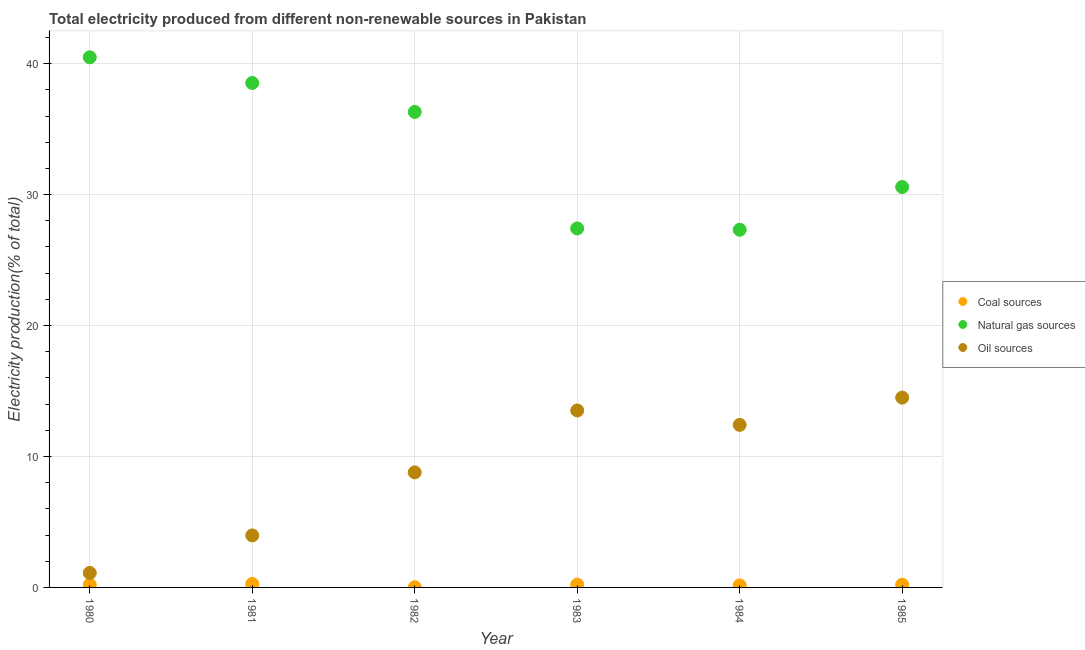How many different coloured dotlines are there?
Offer a terse response. 3. What is the percentage of electricity produced by natural gas in 1981?
Provide a succinct answer. 38.53. Across all years, what is the maximum percentage of electricity produced by natural gas?
Your response must be concise. 40.48. Across all years, what is the minimum percentage of electricity produced by coal?
Provide a short and direct response. 0.02. In which year was the percentage of electricity produced by coal maximum?
Your answer should be very brief. 1981. In which year was the percentage of electricity produced by coal minimum?
Give a very brief answer. 1982. What is the total percentage of electricity produced by natural gas in the graph?
Keep it short and to the point. 200.63. What is the difference between the percentage of electricity produced by coal in 1980 and that in 1985?
Give a very brief answer. -0. What is the difference between the percentage of electricity produced by natural gas in 1982 and the percentage of electricity produced by coal in 1980?
Your answer should be very brief. 36.11. What is the average percentage of electricity produced by natural gas per year?
Provide a short and direct response. 33.44. In the year 1980, what is the difference between the percentage of electricity produced by coal and percentage of electricity produced by oil sources?
Keep it short and to the point. -0.91. What is the ratio of the percentage of electricity produced by natural gas in 1981 to that in 1985?
Ensure brevity in your answer.  1.26. Is the percentage of electricity produced by oil sources in 1981 less than that in 1985?
Your answer should be compact. Yes. What is the difference between the highest and the second highest percentage of electricity produced by coal?
Ensure brevity in your answer.  0.05. What is the difference between the highest and the lowest percentage of electricity produced by oil sources?
Ensure brevity in your answer.  13.39. In how many years, is the percentage of electricity produced by natural gas greater than the average percentage of electricity produced by natural gas taken over all years?
Keep it short and to the point. 3. Is it the case that in every year, the sum of the percentage of electricity produced by coal and percentage of electricity produced by natural gas is greater than the percentage of electricity produced by oil sources?
Provide a succinct answer. Yes. How many years are there in the graph?
Your response must be concise. 6. What is the difference between two consecutive major ticks on the Y-axis?
Offer a terse response. 10. How are the legend labels stacked?
Your answer should be compact. Vertical. What is the title of the graph?
Give a very brief answer. Total electricity produced from different non-renewable sources in Pakistan. What is the label or title of the X-axis?
Offer a very short reply. Year. What is the Electricity production(% of total) in Coal sources in 1980?
Your answer should be compact. 0.2. What is the Electricity production(% of total) in Natural gas sources in 1980?
Ensure brevity in your answer.  40.48. What is the Electricity production(% of total) of Oil sources in 1980?
Your answer should be compact. 1.11. What is the Electricity production(% of total) of Coal sources in 1981?
Your response must be concise. 0.27. What is the Electricity production(% of total) of Natural gas sources in 1981?
Provide a short and direct response. 38.53. What is the Electricity production(% of total) in Oil sources in 1981?
Keep it short and to the point. 3.97. What is the Electricity production(% of total) in Coal sources in 1982?
Offer a very short reply. 0.02. What is the Electricity production(% of total) of Natural gas sources in 1982?
Your answer should be compact. 36.31. What is the Electricity production(% of total) in Oil sources in 1982?
Your response must be concise. 8.79. What is the Electricity production(% of total) in Coal sources in 1983?
Offer a terse response. 0.21. What is the Electricity production(% of total) of Natural gas sources in 1983?
Provide a succinct answer. 27.42. What is the Electricity production(% of total) of Oil sources in 1983?
Offer a terse response. 13.51. What is the Electricity production(% of total) in Coal sources in 1984?
Your response must be concise. 0.16. What is the Electricity production(% of total) in Natural gas sources in 1984?
Give a very brief answer. 27.31. What is the Electricity production(% of total) of Oil sources in 1984?
Your answer should be compact. 12.41. What is the Electricity production(% of total) of Coal sources in 1985?
Your answer should be compact. 0.2. What is the Electricity production(% of total) in Natural gas sources in 1985?
Offer a terse response. 30.58. What is the Electricity production(% of total) of Oil sources in 1985?
Your answer should be very brief. 14.5. Across all years, what is the maximum Electricity production(% of total) in Coal sources?
Provide a short and direct response. 0.27. Across all years, what is the maximum Electricity production(% of total) in Natural gas sources?
Offer a very short reply. 40.48. Across all years, what is the maximum Electricity production(% of total) of Oil sources?
Your response must be concise. 14.5. Across all years, what is the minimum Electricity production(% of total) of Coal sources?
Your answer should be very brief. 0.02. Across all years, what is the minimum Electricity production(% of total) in Natural gas sources?
Ensure brevity in your answer.  27.31. Across all years, what is the minimum Electricity production(% of total) in Oil sources?
Provide a short and direct response. 1.11. What is the total Electricity production(% of total) of Coal sources in the graph?
Offer a terse response. 1.06. What is the total Electricity production(% of total) in Natural gas sources in the graph?
Give a very brief answer. 200.63. What is the total Electricity production(% of total) in Oil sources in the graph?
Your response must be concise. 54.29. What is the difference between the Electricity production(% of total) of Coal sources in 1980 and that in 1981?
Offer a terse response. -0.07. What is the difference between the Electricity production(% of total) of Natural gas sources in 1980 and that in 1981?
Ensure brevity in your answer.  1.96. What is the difference between the Electricity production(% of total) of Oil sources in 1980 and that in 1981?
Your response must be concise. -2.86. What is the difference between the Electricity production(% of total) of Coal sources in 1980 and that in 1982?
Provide a succinct answer. 0.18. What is the difference between the Electricity production(% of total) in Natural gas sources in 1980 and that in 1982?
Your response must be concise. 4.17. What is the difference between the Electricity production(% of total) of Oil sources in 1980 and that in 1982?
Your response must be concise. -7.68. What is the difference between the Electricity production(% of total) of Coal sources in 1980 and that in 1983?
Your answer should be compact. -0.01. What is the difference between the Electricity production(% of total) of Natural gas sources in 1980 and that in 1983?
Give a very brief answer. 13.07. What is the difference between the Electricity production(% of total) in Oil sources in 1980 and that in 1983?
Your answer should be very brief. -12.41. What is the difference between the Electricity production(% of total) of Coal sources in 1980 and that in 1984?
Ensure brevity in your answer.  0.04. What is the difference between the Electricity production(% of total) of Natural gas sources in 1980 and that in 1984?
Your response must be concise. 13.17. What is the difference between the Electricity production(% of total) in Oil sources in 1980 and that in 1984?
Your response must be concise. -11.3. What is the difference between the Electricity production(% of total) in Coal sources in 1980 and that in 1985?
Keep it short and to the point. -0. What is the difference between the Electricity production(% of total) in Natural gas sources in 1980 and that in 1985?
Your answer should be compact. 9.9. What is the difference between the Electricity production(% of total) of Oil sources in 1980 and that in 1985?
Ensure brevity in your answer.  -13.39. What is the difference between the Electricity production(% of total) of Coal sources in 1981 and that in 1982?
Provide a short and direct response. 0.25. What is the difference between the Electricity production(% of total) in Natural gas sources in 1981 and that in 1982?
Make the answer very short. 2.21. What is the difference between the Electricity production(% of total) in Oil sources in 1981 and that in 1982?
Your response must be concise. -4.81. What is the difference between the Electricity production(% of total) of Coal sources in 1981 and that in 1983?
Give a very brief answer. 0.05. What is the difference between the Electricity production(% of total) of Natural gas sources in 1981 and that in 1983?
Your answer should be very brief. 11.11. What is the difference between the Electricity production(% of total) of Oil sources in 1981 and that in 1983?
Give a very brief answer. -9.54. What is the difference between the Electricity production(% of total) of Coal sources in 1981 and that in 1984?
Your answer should be very brief. 0.11. What is the difference between the Electricity production(% of total) in Natural gas sources in 1981 and that in 1984?
Your response must be concise. 11.21. What is the difference between the Electricity production(% of total) of Oil sources in 1981 and that in 1984?
Provide a succinct answer. -8.44. What is the difference between the Electricity production(% of total) of Coal sources in 1981 and that in 1985?
Give a very brief answer. 0.06. What is the difference between the Electricity production(% of total) of Natural gas sources in 1981 and that in 1985?
Your answer should be very brief. 7.95. What is the difference between the Electricity production(% of total) of Oil sources in 1981 and that in 1985?
Ensure brevity in your answer.  -10.53. What is the difference between the Electricity production(% of total) of Coal sources in 1982 and that in 1983?
Make the answer very short. -0.2. What is the difference between the Electricity production(% of total) in Natural gas sources in 1982 and that in 1983?
Your answer should be compact. 8.9. What is the difference between the Electricity production(% of total) of Oil sources in 1982 and that in 1983?
Your response must be concise. -4.73. What is the difference between the Electricity production(% of total) of Coal sources in 1982 and that in 1984?
Provide a short and direct response. -0.14. What is the difference between the Electricity production(% of total) in Natural gas sources in 1982 and that in 1984?
Offer a very short reply. 9. What is the difference between the Electricity production(% of total) of Oil sources in 1982 and that in 1984?
Provide a short and direct response. -3.63. What is the difference between the Electricity production(% of total) in Coal sources in 1982 and that in 1985?
Ensure brevity in your answer.  -0.19. What is the difference between the Electricity production(% of total) of Natural gas sources in 1982 and that in 1985?
Your answer should be very brief. 5.73. What is the difference between the Electricity production(% of total) of Oil sources in 1982 and that in 1985?
Offer a terse response. -5.71. What is the difference between the Electricity production(% of total) in Coal sources in 1983 and that in 1984?
Ensure brevity in your answer.  0.06. What is the difference between the Electricity production(% of total) in Natural gas sources in 1983 and that in 1984?
Offer a very short reply. 0.1. What is the difference between the Electricity production(% of total) in Oil sources in 1983 and that in 1984?
Ensure brevity in your answer.  1.1. What is the difference between the Electricity production(% of total) in Coal sources in 1983 and that in 1985?
Provide a short and direct response. 0.01. What is the difference between the Electricity production(% of total) of Natural gas sources in 1983 and that in 1985?
Your answer should be very brief. -3.16. What is the difference between the Electricity production(% of total) in Oil sources in 1983 and that in 1985?
Provide a succinct answer. -0.98. What is the difference between the Electricity production(% of total) in Coal sources in 1984 and that in 1985?
Offer a very short reply. -0.05. What is the difference between the Electricity production(% of total) in Natural gas sources in 1984 and that in 1985?
Your answer should be compact. -3.27. What is the difference between the Electricity production(% of total) of Oil sources in 1984 and that in 1985?
Your response must be concise. -2.09. What is the difference between the Electricity production(% of total) of Coal sources in 1980 and the Electricity production(% of total) of Natural gas sources in 1981?
Provide a succinct answer. -38.33. What is the difference between the Electricity production(% of total) in Coal sources in 1980 and the Electricity production(% of total) in Oil sources in 1981?
Your answer should be very brief. -3.77. What is the difference between the Electricity production(% of total) in Natural gas sources in 1980 and the Electricity production(% of total) in Oil sources in 1981?
Make the answer very short. 36.51. What is the difference between the Electricity production(% of total) in Coal sources in 1980 and the Electricity production(% of total) in Natural gas sources in 1982?
Your answer should be compact. -36.11. What is the difference between the Electricity production(% of total) of Coal sources in 1980 and the Electricity production(% of total) of Oil sources in 1982?
Provide a succinct answer. -8.59. What is the difference between the Electricity production(% of total) in Natural gas sources in 1980 and the Electricity production(% of total) in Oil sources in 1982?
Give a very brief answer. 31.7. What is the difference between the Electricity production(% of total) in Coal sources in 1980 and the Electricity production(% of total) in Natural gas sources in 1983?
Make the answer very short. -27.21. What is the difference between the Electricity production(% of total) in Coal sources in 1980 and the Electricity production(% of total) in Oil sources in 1983?
Offer a very short reply. -13.31. What is the difference between the Electricity production(% of total) of Natural gas sources in 1980 and the Electricity production(% of total) of Oil sources in 1983?
Provide a succinct answer. 26.97. What is the difference between the Electricity production(% of total) in Coal sources in 1980 and the Electricity production(% of total) in Natural gas sources in 1984?
Give a very brief answer. -27.11. What is the difference between the Electricity production(% of total) in Coal sources in 1980 and the Electricity production(% of total) in Oil sources in 1984?
Keep it short and to the point. -12.21. What is the difference between the Electricity production(% of total) in Natural gas sources in 1980 and the Electricity production(% of total) in Oil sources in 1984?
Offer a very short reply. 28.07. What is the difference between the Electricity production(% of total) in Coal sources in 1980 and the Electricity production(% of total) in Natural gas sources in 1985?
Your answer should be very brief. -30.38. What is the difference between the Electricity production(% of total) in Coal sources in 1980 and the Electricity production(% of total) in Oil sources in 1985?
Your answer should be compact. -14.3. What is the difference between the Electricity production(% of total) in Natural gas sources in 1980 and the Electricity production(% of total) in Oil sources in 1985?
Ensure brevity in your answer.  25.99. What is the difference between the Electricity production(% of total) of Coal sources in 1981 and the Electricity production(% of total) of Natural gas sources in 1982?
Keep it short and to the point. -36.05. What is the difference between the Electricity production(% of total) in Coal sources in 1981 and the Electricity production(% of total) in Oil sources in 1982?
Offer a terse response. -8.52. What is the difference between the Electricity production(% of total) in Natural gas sources in 1981 and the Electricity production(% of total) in Oil sources in 1982?
Make the answer very short. 29.74. What is the difference between the Electricity production(% of total) in Coal sources in 1981 and the Electricity production(% of total) in Natural gas sources in 1983?
Your response must be concise. -27.15. What is the difference between the Electricity production(% of total) of Coal sources in 1981 and the Electricity production(% of total) of Oil sources in 1983?
Ensure brevity in your answer.  -13.25. What is the difference between the Electricity production(% of total) of Natural gas sources in 1981 and the Electricity production(% of total) of Oil sources in 1983?
Give a very brief answer. 25.01. What is the difference between the Electricity production(% of total) of Coal sources in 1981 and the Electricity production(% of total) of Natural gas sources in 1984?
Your answer should be compact. -27.04. What is the difference between the Electricity production(% of total) of Coal sources in 1981 and the Electricity production(% of total) of Oil sources in 1984?
Offer a very short reply. -12.14. What is the difference between the Electricity production(% of total) in Natural gas sources in 1981 and the Electricity production(% of total) in Oil sources in 1984?
Your answer should be compact. 26.11. What is the difference between the Electricity production(% of total) of Coal sources in 1981 and the Electricity production(% of total) of Natural gas sources in 1985?
Your answer should be compact. -30.31. What is the difference between the Electricity production(% of total) in Coal sources in 1981 and the Electricity production(% of total) in Oil sources in 1985?
Provide a succinct answer. -14.23. What is the difference between the Electricity production(% of total) in Natural gas sources in 1981 and the Electricity production(% of total) in Oil sources in 1985?
Your answer should be compact. 24.03. What is the difference between the Electricity production(% of total) of Coal sources in 1982 and the Electricity production(% of total) of Natural gas sources in 1983?
Offer a terse response. -27.4. What is the difference between the Electricity production(% of total) in Coal sources in 1982 and the Electricity production(% of total) in Oil sources in 1983?
Offer a very short reply. -13.5. What is the difference between the Electricity production(% of total) of Natural gas sources in 1982 and the Electricity production(% of total) of Oil sources in 1983?
Your answer should be very brief. 22.8. What is the difference between the Electricity production(% of total) of Coal sources in 1982 and the Electricity production(% of total) of Natural gas sources in 1984?
Give a very brief answer. -27.3. What is the difference between the Electricity production(% of total) of Coal sources in 1982 and the Electricity production(% of total) of Oil sources in 1984?
Make the answer very short. -12.4. What is the difference between the Electricity production(% of total) of Natural gas sources in 1982 and the Electricity production(% of total) of Oil sources in 1984?
Make the answer very short. 23.9. What is the difference between the Electricity production(% of total) of Coal sources in 1982 and the Electricity production(% of total) of Natural gas sources in 1985?
Ensure brevity in your answer.  -30.56. What is the difference between the Electricity production(% of total) in Coal sources in 1982 and the Electricity production(% of total) in Oil sources in 1985?
Your answer should be very brief. -14.48. What is the difference between the Electricity production(% of total) in Natural gas sources in 1982 and the Electricity production(% of total) in Oil sources in 1985?
Ensure brevity in your answer.  21.81. What is the difference between the Electricity production(% of total) of Coal sources in 1983 and the Electricity production(% of total) of Natural gas sources in 1984?
Keep it short and to the point. -27.1. What is the difference between the Electricity production(% of total) in Coal sources in 1983 and the Electricity production(% of total) in Oil sources in 1984?
Keep it short and to the point. -12.2. What is the difference between the Electricity production(% of total) in Natural gas sources in 1983 and the Electricity production(% of total) in Oil sources in 1984?
Offer a very short reply. 15. What is the difference between the Electricity production(% of total) of Coal sources in 1983 and the Electricity production(% of total) of Natural gas sources in 1985?
Make the answer very short. -30.37. What is the difference between the Electricity production(% of total) in Coal sources in 1983 and the Electricity production(% of total) in Oil sources in 1985?
Provide a succinct answer. -14.28. What is the difference between the Electricity production(% of total) in Natural gas sources in 1983 and the Electricity production(% of total) in Oil sources in 1985?
Your response must be concise. 12.92. What is the difference between the Electricity production(% of total) in Coal sources in 1984 and the Electricity production(% of total) in Natural gas sources in 1985?
Your answer should be compact. -30.42. What is the difference between the Electricity production(% of total) in Coal sources in 1984 and the Electricity production(% of total) in Oil sources in 1985?
Provide a succinct answer. -14.34. What is the difference between the Electricity production(% of total) in Natural gas sources in 1984 and the Electricity production(% of total) in Oil sources in 1985?
Ensure brevity in your answer.  12.81. What is the average Electricity production(% of total) of Coal sources per year?
Offer a very short reply. 0.18. What is the average Electricity production(% of total) in Natural gas sources per year?
Keep it short and to the point. 33.44. What is the average Electricity production(% of total) in Oil sources per year?
Your response must be concise. 9.05. In the year 1980, what is the difference between the Electricity production(% of total) in Coal sources and Electricity production(% of total) in Natural gas sources?
Provide a short and direct response. -40.28. In the year 1980, what is the difference between the Electricity production(% of total) of Coal sources and Electricity production(% of total) of Oil sources?
Give a very brief answer. -0.91. In the year 1980, what is the difference between the Electricity production(% of total) of Natural gas sources and Electricity production(% of total) of Oil sources?
Offer a terse response. 39.37. In the year 1981, what is the difference between the Electricity production(% of total) of Coal sources and Electricity production(% of total) of Natural gas sources?
Offer a terse response. -38.26. In the year 1981, what is the difference between the Electricity production(% of total) in Coal sources and Electricity production(% of total) in Oil sources?
Give a very brief answer. -3.7. In the year 1981, what is the difference between the Electricity production(% of total) in Natural gas sources and Electricity production(% of total) in Oil sources?
Offer a terse response. 34.55. In the year 1982, what is the difference between the Electricity production(% of total) of Coal sources and Electricity production(% of total) of Natural gas sources?
Your answer should be compact. -36.3. In the year 1982, what is the difference between the Electricity production(% of total) in Coal sources and Electricity production(% of total) in Oil sources?
Your response must be concise. -8.77. In the year 1982, what is the difference between the Electricity production(% of total) in Natural gas sources and Electricity production(% of total) in Oil sources?
Make the answer very short. 27.53. In the year 1983, what is the difference between the Electricity production(% of total) in Coal sources and Electricity production(% of total) in Natural gas sources?
Keep it short and to the point. -27.2. In the year 1983, what is the difference between the Electricity production(% of total) in Coal sources and Electricity production(% of total) in Oil sources?
Your answer should be very brief. -13.3. In the year 1983, what is the difference between the Electricity production(% of total) in Natural gas sources and Electricity production(% of total) in Oil sources?
Your answer should be very brief. 13.9. In the year 1984, what is the difference between the Electricity production(% of total) in Coal sources and Electricity production(% of total) in Natural gas sources?
Offer a terse response. -27.16. In the year 1984, what is the difference between the Electricity production(% of total) in Coal sources and Electricity production(% of total) in Oil sources?
Offer a terse response. -12.26. In the year 1984, what is the difference between the Electricity production(% of total) of Natural gas sources and Electricity production(% of total) of Oil sources?
Give a very brief answer. 14.9. In the year 1985, what is the difference between the Electricity production(% of total) in Coal sources and Electricity production(% of total) in Natural gas sources?
Make the answer very short. -30.37. In the year 1985, what is the difference between the Electricity production(% of total) of Coal sources and Electricity production(% of total) of Oil sources?
Give a very brief answer. -14.29. In the year 1985, what is the difference between the Electricity production(% of total) of Natural gas sources and Electricity production(% of total) of Oil sources?
Give a very brief answer. 16.08. What is the ratio of the Electricity production(% of total) in Coal sources in 1980 to that in 1981?
Make the answer very short. 0.75. What is the ratio of the Electricity production(% of total) in Natural gas sources in 1980 to that in 1981?
Offer a terse response. 1.05. What is the ratio of the Electricity production(% of total) of Oil sources in 1980 to that in 1981?
Your answer should be very brief. 0.28. What is the ratio of the Electricity production(% of total) of Coal sources in 1980 to that in 1982?
Keep it short and to the point. 11.81. What is the ratio of the Electricity production(% of total) in Natural gas sources in 1980 to that in 1982?
Make the answer very short. 1.11. What is the ratio of the Electricity production(% of total) in Oil sources in 1980 to that in 1982?
Your response must be concise. 0.13. What is the ratio of the Electricity production(% of total) of Coal sources in 1980 to that in 1983?
Keep it short and to the point. 0.94. What is the ratio of the Electricity production(% of total) of Natural gas sources in 1980 to that in 1983?
Your answer should be very brief. 1.48. What is the ratio of the Electricity production(% of total) in Oil sources in 1980 to that in 1983?
Ensure brevity in your answer.  0.08. What is the ratio of the Electricity production(% of total) in Coal sources in 1980 to that in 1984?
Provide a succinct answer. 1.29. What is the ratio of the Electricity production(% of total) of Natural gas sources in 1980 to that in 1984?
Ensure brevity in your answer.  1.48. What is the ratio of the Electricity production(% of total) in Oil sources in 1980 to that in 1984?
Your response must be concise. 0.09. What is the ratio of the Electricity production(% of total) in Coal sources in 1980 to that in 1985?
Ensure brevity in your answer.  0.98. What is the ratio of the Electricity production(% of total) in Natural gas sources in 1980 to that in 1985?
Make the answer very short. 1.32. What is the ratio of the Electricity production(% of total) of Oil sources in 1980 to that in 1985?
Your response must be concise. 0.08. What is the ratio of the Electricity production(% of total) in Coal sources in 1981 to that in 1982?
Offer a very short reply. 15.78. What is the ratio of the Electricity production(% of total) in Natural gas sources in 1981 to that in 1982?
Ensure brevity in your answer.  1.06. What is the ratio of the Electricity production(% of total) of Oil sources in 1981 to that in 1982?
Your answer should be compact. 0.45. What is the ratio of the Electricity production(% of total) of Coal sources in 1981 to that in 1983?
Make the answer very short. 1.26. What is the ratio of the Electricity production(% of total) in Natural gas sources in 1981 to that in 1983?
Keep it short and to the point. 1.41. What is the ratio of the Electricity production(% of total) of Oil sources in 1981 to that in 1983?
Your answer should be compact. 0.29. What is the ratio of the Electricity production(% of total) of Coal sources in 1981 to that in 1984?
Give a very brief answer. 1.72. What is the ratio of the Electricity production(% of total) of Natural gas sources in 1981 to that in 1984?
Offer a very short reply. 1.41. What is the ratio of the Electricity production(% of total) in Oil sources in 1981 to that in 1984?
Provide a short and direct response. 0.32. What is the ratio of the Electricity production(% of total) of Coal sources in 1981 to that in 1985?
Give a very brief answer. 1.31. What is the ratio of the Electricity production(% of total) of Natural gas sources in 1981 to that in 1985?
Your answer should be very brief. 1.26. What is the ratio of the Electricity production(% of total) in Oil sources in 1981 to that in 1985?
Ensure brevity in your answer.  0.27. What is the ratio of the Electricity production(% of total) of Coal sources in 1982 to that in 1983?
Provide a succinct answer. 0.08. What is the ratio of the Electricity production(% of total) in Natural gas sources in 1982 to that in 1983?
Make the answer very short. 1.32. What is the ratio of the Electricity production(% of total) of Oil sources in 1982 to that in 1983?
Ensure brevity in your answer.  0.65. What is the ratio of the Electricity production(% of total) of Coal sources in 1982 to that in 1984?
Keep it short and to the point. 0.11. What is the ratio of the Electricity production(% of total) of Natural gas sources in 1982 to that in 1984?
Offer a very short reply. 1.33. What is the ratio of the Electricity production(% of total) in Oil sources in 1982 to that in 1984?
Offer a terse response. 0.71. What is the ratio of the Electricity production(% of total) in Coal sources in 1982 to that in 1985?
Ensure brevity in your answer.  0.08. What is the ratio of the Electricity production(% of total) of Natural gas sources in 1982 to that in 1985?
Provide a short and direct response. 1.19. What is the ratio of the Electricity production(% of total) of Oil sources in 1982 to that in 1985?
Give a very brief answer. 0.61. What is the ratio of the Electricity production(% of total) of Coal sources in 1983 to that in 1984?
Offer a very short reply. 1.37. What is the ratio of the Electricity production(% of total) in Oil sources in 1983 to that in 1984?
Ensure brevity in your answer.  1.09. What is the ratio of the Electricity production(% of total) in Coal sources in 1983 to that in 1985?
Make the answer very short. 1.04. What is the ratio of the Electricity production(% of total) in Natural gas sources in 1983 to that in 1985?
Your response must be concise. 0.9. What is the ratio of the Electricity production(% of total) in Oil sources in 1983 to that in 1985?
Offer a terse response. 0.93. What is the ratio of the Electricity production(% of total) of Coal sources in 1984 to that in 1985?
Your answer should be compact. 0.76. What is the ratio of the Electricity production(% of total) of Natural gas sources in 1984 to that in 1985?
Your response must be concise. 0.89. What is the ratio of the Electricity production(% of total) of Oil sources in 1984 to that in 1985?
Ensure brevity in your answer.  0.86. What is the difference between the highest and the second highest Electricity production(% of total) of Coal sources?
Offer a terse response. 0.05. What is the difference between the highest and the second highest Electricity production(% of total) of Natural gas sources?
Offer a very short reply. 1.96. What is the difference between the highest and the second highest Electricity production(% of total) of Oil sources?
Give a very brief answer. 0.98. What is the difference between the highest and the lowest Electricity production(% of total) of Coal sources?
Offer a very short reply. 0.25. What is the difference between the highest and the lowest Electricity production(% of total) in Natural gas sources?
Your response must be concise. 13.17. What is the difference between the highest and the lowest Electricity production(% of total) of Oil sources?
Provide a short and direct response. 13.39. 